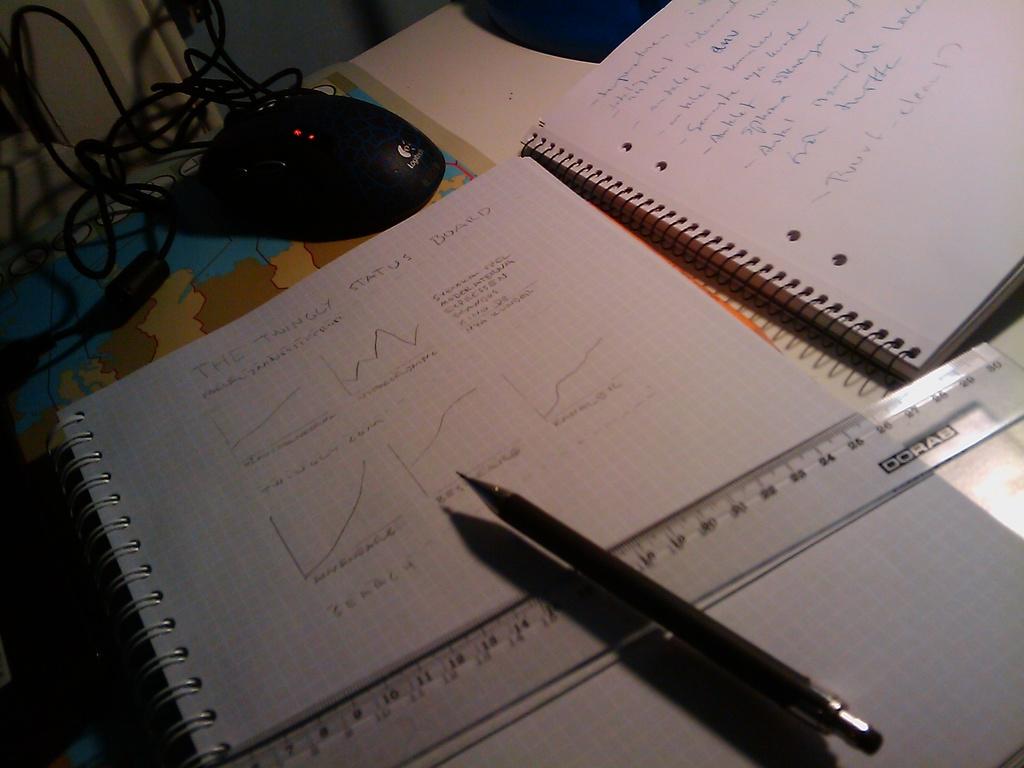What brand is the mouse?
Offer a terse response. Logitech. 